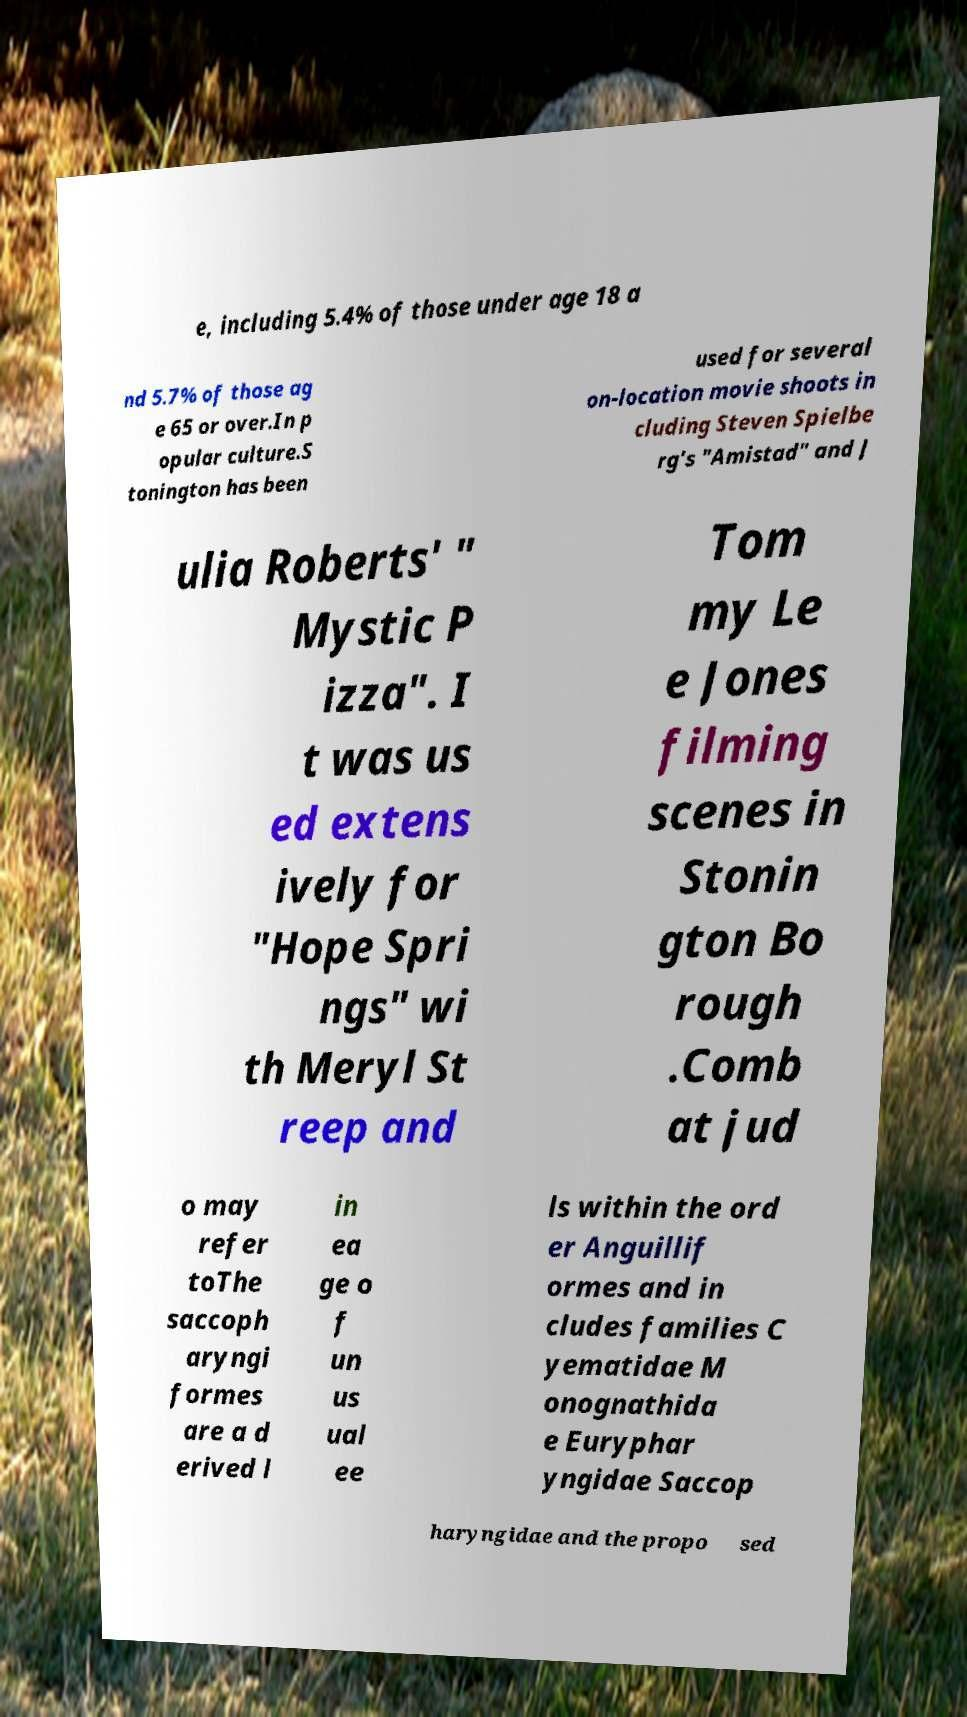Could you extract and type out the text from this image? e, including 5.4% of those under age 18 a nd 5.7% of those ag e 65 or over.In p opular culture.S tonington has been used for several on-location movie shoots in cluding Steven Spielbe rg's "Amistad" and J ulia Roberts' " Mystic P izza". I t was us ed extens ively for "Hope Spri ngs" wi th Meryl St reep and Tom my Le e Jones filming scenes in Stonin gton Bo rough .Comb at jud o may refer toThe saccoph aryngi formes are a d erived l in ea ge o f un us ual ee ls within the ord er Anguillif ormes and in cludes families C yematidae M onognathida e Euryphar yngidae Saccop haryngidae and the propo sed 